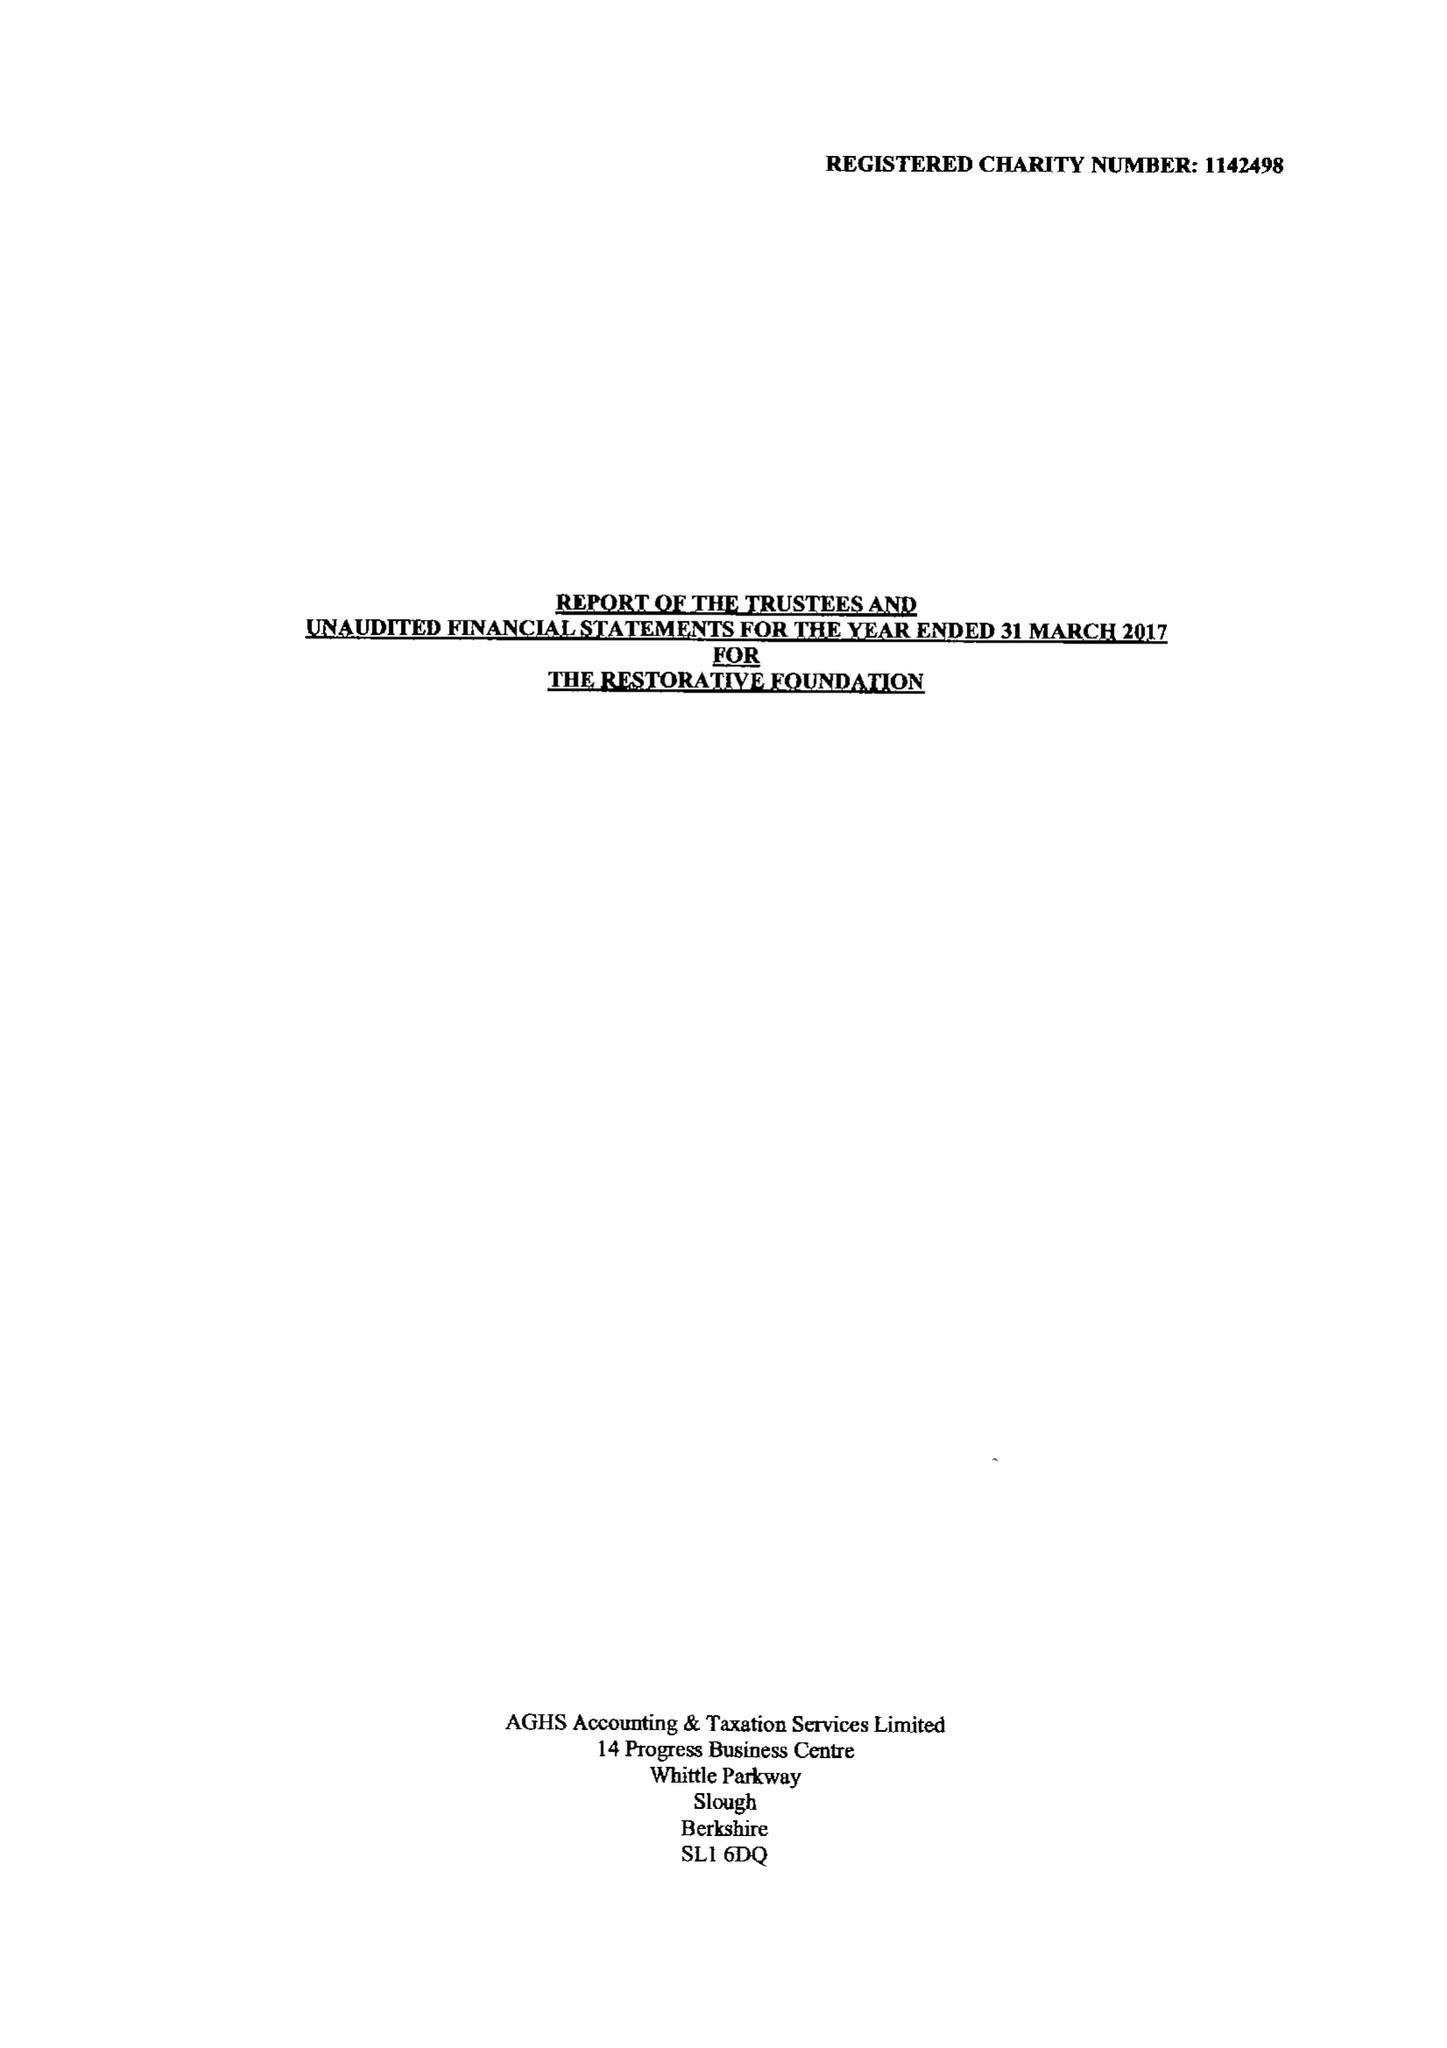What is the value for the spending_annually_in_british_pounds?
Answer the question using a single word or phrase. 55835.00 